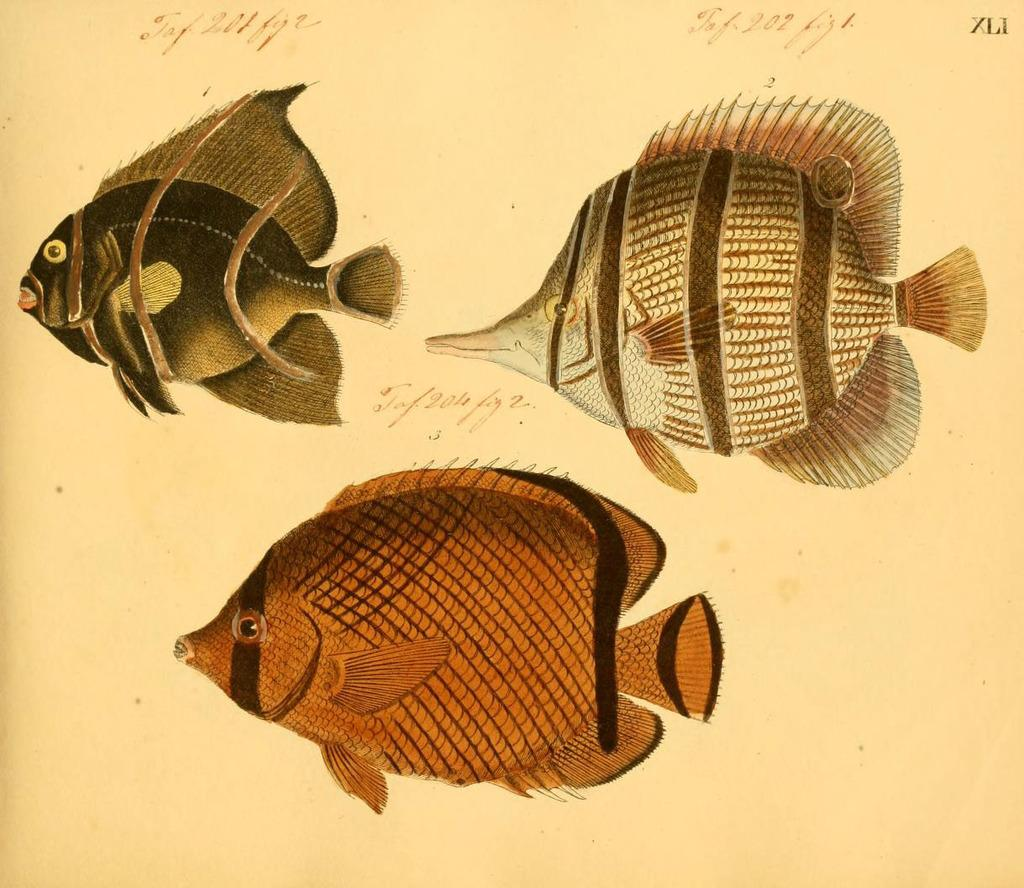How many fish pictures are in the image? There are three different fish pictures in the image. What type of worm can be seen crawling on the bed in the image? There is no worm or bed present in the image; it only contains three different fish pictures. 